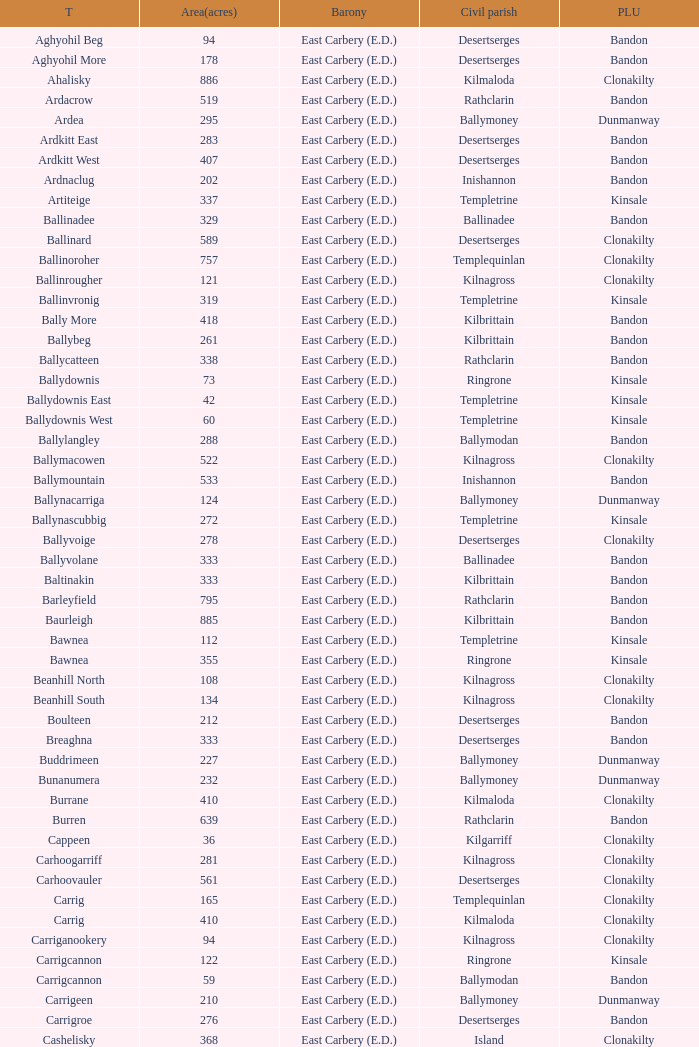Parse the table in full. {'header': ['T', 'Area(acres)', 'Barony', 'Civil parish', 'PLU'], 'rows': [['Aghyohil Beg', '94', 'East Carbery (E.D.)', 'Desertserges', 'Bandon'], ['Aghyohil More', '178', 'East Carbery (E.D.)', 'Desertserges', 'Bandon'], ['Ahalisky', '886', 'East Carbery (E.D.)', 'Kilmaloda', 'Clonakilty'], ['Ardacrow', '519', 'East Carbery (E.D.)', 'Rathclarin', 'Bandon'], ['Ardea', '295', 'East Carbery (E.D.)', 'Ballymoney', 'Dunmanway'], ['Ardkitt East', '283', 'East Carbery (E.D.)', 'Desertserges', 'Bandon'], ['Ardkitt West', '407', 'East Carbery (E.D.)', 'Desertserges', 'Bandon'], ['Ardnaclug', '202', 'East Carbery (E.D.)', 'Inishannon', 'Bandon'], ['Artiteige', '337', 'East Carbery (E.D.)', 'Templetrine', 'Kinsale'], ['Ballinadee', '329', 'East Carbery (E.D.)', 'Ballinadee', 'Bandon'], ['Ballinard', '589', 'East Carbery (E.D.)', 'Desertserges', 'Clonakilty'], ['Ballinoroher', '757', 'East Carbery (E.D.)', 'Templequinlan', 'Clonakilty'], ['Ballinrougher', '121', 'East Carbery (E.D.)', 'Kilnagross', 'Clonakilty'], ['Ballinvronig', '319', 'East Carbery (E.D.)', 'Templetrine', 'Kinsale'], ['Bally More', '418', 'East Carbery (E.D.)', 'Kilbrittain', 'Bandon'], ['Ballybeg', '261', 'East Carbery (E.D.)', 'Kilbrittain', 'Bandon'], ['Ballycatteen', '338', 'East Carbery (E.D.)', 'Rathclarin', 'Bandon'], ['Ballydownis', '73', 'East Carbery (E.D.)', 'Ringrone', 'Kinsale'], ['Ballydownis East', '42', 'East Carbery (E.D.)', 'Templetrine', 'Kinsale'], ['Ballydownis West', '60', 'East Carbery (E.D.)', 'Templetrine', 'Kinsale'], ['Ballylangley', '288', 'East Carbery (E.D.)', 'Ballymodan', 'Bandon'], ['Ballymacowen', '522', 'East Carbery (E.D.)', 'Kilnagross', 'Clonakilty'], ['Ballymountain', '533', 'East Carbery (E.D.)', 'Inishannon', 'Bandon'], ['Ballynacarriga', '124', 'East Carbery (E.D.)', 'Ballymoney', 'Dunmanway'], ['Ballynascubbig', '272', 'East Carbery (E.D.)', 'Templetrine', 'Kinsale'], ['Ballyvoige', '278', 'East Carbery (E.D.)', 'Desertserges', 'Clonakilty'], ['Ballyvolane', '333', 'East Carbery (E.D.)', 'Ballinadee', 'Bandon'], ['Baltinakin', '333', 'East Carbery (E.D.)', 'Kilbrittain', 'Bandon'], ['Barleyfield', '795', 'East Carbery (E.D.)', 'Rathclarin', 'Bandon'], ['Baurleigh', '885', 'East Carbery (E.D.)', 'Kilbrittain', 'Bandon'], ['Bawnea', '112', 'East Carbery (E.D.)', 'Templetrine', 'Kinsale'], ['Bawnea', '355', 'East Carbery (E.D.)', 'Ringrone', 'Kinsale'], ['Beanhill North', '108', 'East Carbery (E.D.)', 'Kilnagross', 'Clonakilty'], ['Beanhill South', '134', 'East Carbery (E.D.)', 'Kilnagross', 'Clonakilty'], ['Boulteen', '212', 'East Carbery (E.D.)', 'Desertserges', 'Bandon'], ['Breaghna', '333', 'East Carbery (E.D.)', 'Desertserges', 'Bandon'], ['Buddrimeen', '227', 'East Carbery (E.D.)', 'Ballymoney', 'Dunmanway'], ['Bunanumera', '232', 'East Carbery (E.D.)', 'Ballymoney', 'Dunmanway'], ['Burrane', '410', 'East Carbery (E.D.)', 'Kilmaloda', 'Clonakilty'], ['Burren', '639', 'East Carbery (E.D.)', 'Rathclarin', 'Bandon'], ['Cappeen', '36', 'East Carbery (E.D.)', 'Kilgarriff', 'Clonakilty'], ['Carhoogarriff', '281', 'East Carbery (E.D.)', 'Kilnagross', 'Clonakilty'], ['Carhoovauler', '561', 'East Carbery (E.D.)', 'Desertserges', 'Clonakilty'], ['Carrig', '165', 'East Carbery (E.D.)', 'Templequinlan', 'Clonakilty'], ['Carrig', '410', 'East Carbery (E.D.)', 'Kilmaloda', 'Clonakilty'], ['Carriganookery', '94', 'East Carbery (E.D.)', 'Kilnagross', 'Clonakilty'], ['Carrigcannon', '122', 'East Carbery (E.D.)', 'Ringrone', 'Kinsale'], ['Carrigcannon', '59', 'East Carbery (E.D.)', 'Ballymodan', 'Bandon'], ['Carrigeen', '210', 'East Carbery (E.D.)', 'Ballymoney', 'Dunmanway'], ['Carrigroe', '276', 'East Carbery (E.D.)', 'Desertserges', 'Bandon'], ['Cashelisky', '368', 'East Carbery (E.D.)', 'Island', 'Clonakilty'], ['Castlederry', '148', 'East Carbery (E.D.)', 'Desertserges', 'Clonakilty'], ['Clashafree', '477', 'East Carbery (E.D.)', 'Ballymodan', 'Bandon'], ['Clashreagh', '132', 'East Carbery (E.D.)', 'Templetrine', 'Kinsale'], ['Clogagh North', '173', 'East Carbery (E.D.)', 'Kilmaloda', 'Clonakilty'], ['Clogagh South', '282', 'East Carbery (E.D.)', 'Kilmaloda', 'Clonakilty'], ['Cloghane', '488', 'East Carbery (E.D.)', 'Ballinadee', 'Bandon'], ['Clogheenavodig', '70', 'East Carbery (E.D.)', 'Ballymodan', 'Bandon'], ['Cloghmacsimon', '258', 'East Carbery (E.D.)', 'Ballymodan', 'Bandon'], ['Cloheen', '360', 'East Carbery (E.D.)', 'Kilgarriff', 'Clonakilty'], ['Cloheen', '80', 'East Carbery (E.D.)', 'Island', 'Clonakilty'], ['Clonbouig', '209', 'East Carbery (E.D.)', 'Templetrine', 'Kinsale'], ['Clonbouig', '219', 'East Carbery (E.D.)', 'Ringrone', 'Kinsale'], ['Cloncouse', '241', 'East Carbery (E.D.)', 'Ballinadee', 'Bandon'], ['Clooncalla Beg', '219', 'East Carbery (E.D.)', 'Rathclarin', 'Bandon'], ['Clooncalla More', '543', 'East Carbery (E.D.)', 'Rathclarin', 'Bandon'], ['Cloonderreen', '291', 'East Carbery (E.D.)', 'Rathclarin', 'Bandon'], ['Coolmain', '450', 'East Carbery (E.D.)', 'Ringrone', 'Kinsale'], ['Corravreeda East', '258', 'East Carbery (E.D.)', 'Ballymodan', 'Bandon'], ['Corravreeda West', '169', 'East Carbery (E.D.)', 'Ballymodan', 'Bandon'], ['Cripplehill', '125', 'East Carbery (E.D.)', 'Ballymodan', 'Bandon'], ['Cripplehill', '93', 'East Carbery (E.D.)', 'Kilbrittain', 'Bandon'], ['Crohane', '91', 'East Carbery (E.D.)', 'Kilnagross', 'Clonakilty'], ['Crohane East', '108', 'East Carbery (E.D.)', 'Desertserges', 'Clonakilty'], ['Crohane West', '69', 'East Carbery (E.D.)', 'Desertserges', 'Clonakilty'], ['Crohane (or Bandon)', '204', 'East Carbery (E.D.)', 'Desertserges', 'Clonakilty'], ['Crohane (or Bandon)', '250', 'East Carbery (E.D.)', 'Kilnagross', 'Clonakilty'], ['Currabeg', '173', 'East Carbery (E.D.)', 'Ballymoney', 'Dunmanway'], ['Curraghcrowly East', '327', 'East Carbery (E.D.)', 'Ballymoney', 'Dunmanway'], ['Curraghcrowly West', '242', 'East Carbery (E.D.)', 'Ballymoney', 'Dunmanway'], ['Curraghgrane More', '110', 'East Carbery (E.D.)', 'Desert', 'Clonakilty'], ['Currane', '156', 'East Carbery (E.D.)', 'Desertserges', 'Clonakilty'], ['Curranure', '362', 'East Carbery (E.D.)', 'Inishannon', 'Bandon'], ['Currarane', '100', 'East Carbery (E.D.)', 'Templetrine', 'Kinsale'], ['Currarane', '271', 'East Carbery (E.D.)', 'Ringrone', 'Kinsale'], ['Derrigra', '177', 'East Carbery (E.D.)', 'Ballymoney', 'Dunmanway'], ['Derrigra West', '320', 'East Carbery (E.D.)', 'Ballymoney', 'Dunmanway'], ['Derry', '140', 'East Carbery (E.D.)', 'Desertserges', 'Clonakilty'], ['Derrymeeleen', '441', 'East Carbery (E.D.)', 'Desertserges', 'Clonakilty'], ['Desert', '339', 'East Carbery (E.D.)', 'Desert', 'Clonakilty'], ['Drombofinny', '86', 'East Carbery (E.D.)', 'Desertserges', 'Bandon'], ['Dromgarriff', '335', 'East Carbery (E.D.)', 'Kilmaloda', 'Clonakilty'], ['Dromgarriff East', '385', 'East Carbery (E.D.)', 'Kilnagross', 'Clonakilty'], ['Dromgarriff West', '138', 'East Carbery (E.D.)', 'Kilnagross', 'Clonakilty'], ['Dromkeen', '673', 'East Carbery (E.D.)', 'Inishannon', 'Bandon'], ['Edencurra', '516', 'East Carbery (E.D.)', 'Ballymoney', 'Dunmanway'], ['Farran', '502', 'East Carbery (E.D.)', 'Kilmaloda', 'Clonakilty'], ['Farranagow', '99', 'East Carbery (E.D.)', 'Inishannon', 'Bandon'], ['Farrannagark', '290', 'East Carbery (E.D.)', 'Rathclarin', 'Bandon'], ['Farrannasheshery', '304', 'East Carbery (E.D.)', 'Desertserges', 'Bandon'], ['Fourcuil', '125', 'East Carbery (E.D.)', 'Kilgarriff', 'Clonakilty'], ['Fourcuil', '244', 'East Carbery (E.D.)', 'Templebryan', 'Clonakilty'], ['Garranbeg', '170', 'East Carbery (E.D.)', 'Ballymodan', 'Bandon'], ['Garraneanasig', '270', 'East Carbery (E.D.)', 'Ringrone', 'Kinsale'], ['Garraneard', '276', 'East Carbery (E.D.)', 'Kilnagross', 'Clonakilty'], ['Garranecore', '144', 'East Carbery (E.D.)', 'Templebryan', 'Clonakilty'], ['Garranecore', '186', 'East Carbery (E.D.)', 'Kilgarriff', 'Clonakilty'], ['Garranefeen', '478', 'East Carbery (E.D.)', 'Rathclarin', 'Bandon'], ['Garraneishal', '121', 'East Carbery (E.D.)', 'Kilnagross', 'Clonakilty'], ['Garranelahan', '126', 'East Carbery (E.D.)', 'Desertserges', 'Bandon'], ['Garranereagh', '398', 'East Carbery (E.D.)', 'Ringrone', 'Kinsale'], ['Garranes', '416', 'East Carbery (E.D.)', 'Desertserges', 'Clonakilty'], ['Garranure', '436', 'East Carbery (E.D.)', 'Ballymoney', 'Dunmanway'], ['Garryndruig', '856', 'East Carbery (E.D.)', 'Rathclarin', 'Bandon'], ['Glan', '194', 'East Carbery (E.D.)', 'Ballymoney', 'Dunmanway'], ['Glanavaud', '98', 'East Carbery (E.D.)', 'Ringrone', 'Kinsale'], ['Glanavirane', '107', 'East Carbery (E.D.)', 'Templetrine', 'Kinsale'], ['Glanavirane', '91', 'East Carbery (E.D.)', 'Ringrone', 'Kinsale'], ['Glanduff', '464', 'East Carbery (E.D.)', 'Rathclarin', 'Bandon'], ['Grillagh', '136', 'East Carbery (E.D.)', 'Kilnagross', 'Clonakilty'], ['Grillagh', '316', 'East Carbery (E.D.)', 'Ballymoney', 'Dunmanway'], ['Hacketstown', '182', 'East Carbery (E.D.)', 'Templetrine', 'Kinsale'], ['Inchafune', '871', 'East Carbery (E.D.)', 'Ballymoney', 'Dunmanway'], ['Inchydoney Island', '474', 'East Carbery (E.D.)', 'Island', 'Clonakilty'], ['Kilbeloge', '216', 'East Carbery (E.D.)', 'Desertserges', 'Clonakilty'], ['Kilbree', '284', 'East Carbery (E.D.)', 'Island', 'Clonakilty'], ['Kilbrittain', '483', 'East Carbery (E.D.)', 'Kilbrittain', 'Bandon'], ['Kilcaskan', '221', 'East Carbery (E.D.)', 'Ballymoney', 'Dunmanway'], ['Kildarra', '463', 'East Carbery (E.D.)', 'Ballinadee', 'Bandon'], ['Kilgarriff', '835', 'East Carbery (E.D.)', 'Kilgarriff', 'Clonakilty'], ['Kilgobbin', '1263', 'East Carbery (E.D.)', 'Ballinadee', 'Bandon'], ['Kill North', '136', 'East Carbery (E.D.)', 'Desertserges', 'Clonakilty'], ['Kill South', '139', 'East Carbery (E.D.)', 'Desertserges', 'Clonakilty'], ['Killanamaul', '220', 'East Carbery (E.D.)', 'Kilbrittain', 'Bandon'], ['Killaneetig', '342', 'East Carbery (E.D.)', 'Ballinadee', 'Bandon'], ['Killavarrig', '708', 'East Carbery (E.D.)', 'Timoleague', 'Clonakilty'], ['Killeen', '309', 'East Carbery (E.D.)', 'Desertserges', 'Clonakilty'], ['Killeens', '132', 'East Carbery (E.D.)', 'Templetrine', 'Kinsale'], ['Kilmacsimon', '219', 'East Carbery (E.D.)', 'Ballinadee', 'Bandon'], ['Kilmaloda', '634', 'East Carbery (E.D.)', 'Kilmaloda', 'Clonakilty'], ['Kilmoylerane North', '306', 'East Carbery (E.D.)', 'Desertserges', 'Clonakilty'], ['Kilmoylerane South', '324', 'East Carbery (E.D.)', 'Desertserges', 'Clonakilty'], ['Kilnameela', '397', 'East Carbery (E.D.)', 'Desertserges', 'Bandon'], ['Kilrush', '189', 'East Carbery (E.D.)', 'Desertserges', 'Bandon'], ['Kilshinahan', '528', 'East Carbery (E.D.)', 'Kilbrittain', 'Bandon'], ['Kilvinane', '199', 'East Carbery (E.D.)', 'Ballymoney', 'Dunmanway'], ['Kilvurra', '356', 'East Carbery (E.D.)', 'Ballymoney', 'Dunmanway'], ['Knockacullen', '381', 'East Carbery (E.D.)', 'Desertserges', 'Clonakilty'], ['Knockaneady', '393', 'East Carbery (E.D.)', 'Ballymoney', 'Dunmanway'], ['Knockaneroe', '127', 'East Carbery (E.D.)', 'Templetrine', 'Kinsale'], ['Knockanreagh', '139', 'East Carbery (E.D.)', 'Ballymodan', 'Bandon'], ['Knockbrown', '312', 'East Carbery (E.D.)', 'Kilbrittain', 'Bandon'], ['Knockbrown', '510', 'East Carbery (E.D.)', 'Kilmaloda', 'Bandon'], ['Knockeenbwee Lower', '213', 'East Carbery (E.D.)', 'Dromdaleague', 'Skibbereen'], ['Knockeenbwee Upper', '229', 'East Carbery (E.D.)', 'Dromdaleague', 'Skibbereen'], ['Knockeencon', '108', 'East Carbery (E.D.)', 'Tullagh', 'Skibbereen'], ['Knockmacool', '241', 'East Carbery (E.D.)', 'Desertserges', 'Bandon'], ['Knocknacurra', '422', 'East Carbery (E.D.)', 'Ballinadee', 'Bandon'], ['Knocknagappul', '507', 'East Carbery (E.D.)', 'Ballinadee', 'Bandon'], ['Knocknanuss', '394', 'East Carbery (E.D.)', 'Desertserges', 'Clonakilty'], ['Knocknastooka', '118', 'East Carbery (E.D.)', 'Desertserges', 'Bandon'], ['Knockroe', '601', 'East Carbery (E.D.)', 'Inishannon', 'Bandon'], ['Knocks', '540', 'East Carbery (E.D.)', 'Desertserges', 'Clonakilty'], ['Knockskagh', '489', 'East Carbery (E.D.)', 'Kilgarriff', 'Clonakilty'], ['Knoppoge', '567', 'East Carbery (E.D.)', 'Kilbrittain', 'Bandon'], ['Lackanalooha', '209', 'East Carbery (E.D.)', 'Kilnagross', 'Clonakilty'], ['Lackenagobidane', '48', 'East Carbery (E.D.)', 'Island', 'Clonakilty'], ['Lisbehegh', '255', 'East Carbery (E.D.)', 'Desertserges', 'Clonakilty'], ['Lisheen', '44', 'East Carbery (E.D.)', 'Templetrine', 'Kinsale'], ['Lisheenaleen', '267', 'East Carbery (E.D.)', 'Rathclarin', 'Bandon'], ['Lisnacunna', '529', 'East Carbery (E.D.)', 'Desertserges', 'Bandon'], ['Lisroe', '91', 'East Carbery (E.D.)', 'Kilgarriff', 'Clonakilty'], ['Lissaphooca', '513', 'East Carbery (E.D.)', 'Ballymodan', 'Bandon'], ['Lisselane', '429', 'East Carbery (E.D.)', 'Kilnagross', 'Clonakilty'], ['Madame', '273', 'East Carbery (E.D.)', 'Kilmaloda', 'Clonakilty'], ['Madame', '41', 'East Carbery (E.D.)', 'Kilnagross', 'Clonakilty'], ['Maulbrack East', '100', 'East Carbery (E.D.)', 'Desertserges', 'Bandon'], ['Maulbrack West', '242', 'East Carbery (E.D.)', 'Desertserges', 'Bandon'], ['Maulmane', '219', 'East Carbery (E.D.)', 'Kilbrittain', 'Bandon'], ['Maulnageragh', '135', 'East Carbery (E.D.)', 'Kilnagross', 'Clonakilty'], ['Maulnarouga North', '81', 'East Carbery (E.D.)', 'Desertserges', 'Bandon'], ['Maulnarouga South', '374', 'East Carbery (E.D.)', 'Desertserges', 'Bandon'], ['Maulnaskehy', '14', 'East Carbery (E.D.)', 'Kilgarriff', 'Clonakilty'], ['Maulrour', '244', 'East Carbery (E.D.)', 'Desertserges', 'Clonakilty'], ['Maulrour', '340', 'East Carbery (E.D.)', 'Kilmaloda', 'Clonakilty'], ['Maulskinlahane', '245', 'East Carbery (E.D.)', 'Kilbrittain', 'Bandon'], ['Miles', '268', 'East Carbery (E.D.)', 'Kilgarriff', 'Clonakilty'], ['Moanarone', '235', 'East Carbery (E.D.)', 'Ballymodan', 'Bandon'], ['Monteen', '589', 'East Carbery (E.D.)', 'Kilmaloda', 'Clonakilty'], ['Phale Lower', '287', 'East Carbery (E.D.)', 'Ballymoney', 'Dunmanway'], ['Phale Upper', '234', 'East Carbery (E.D.)', 'Ballymoney', 'Dunmanway'], ['Ratharoon East', '810', 'East Carbery (E.D.)', 'Ballinadee', 'Bandon'], ['Ratharoon West', '383', 'East Carbery (E.D.)', 'Ballinadee', 'Bandon'], ['Rathdrought', '1242', 'East Carbery (E.D.)', 'Ballinadee', 'Bandon'], ['Reengarrigeen', '560', 'East Carbery (E.D.)', 'Kilmaloda', 'Clonakilty'], ['Reenroe', '123', 'East Carbery (E.D.)', 'Kilgarriff', 'Clonakilty'], ['Rochestown', '104', 'East Carbery (E.D.)', 'Templetrine', 'Kinsale'], ['Rockfort', '308', 'East Carbery (E.D.)', 'Brinny', 'Bandon'], ['Rockhouse', '82', 'East Carbery (E.D.)', 'Ballinadee', 'Bandon'], ['Scartagh', '186', 'East Carbery (E.D.)', 'Kilgarriff', 'Clonakilty'], ['Shanakill', '197', 'East Carbery (E.D.)', 'Rathclarin', 'Bandon'], ['Shanaway East', '386', 'East Carbery (E.D.)', 'Ballymoney', 'Dunmanway'], ['Shanaway Middle', '296', 'East Carbery (E.D.)', 'Ballymoney', 'Dunmanway'], ['Shanaway West', '266', 'East Carbery (E.D.)', 'Ballymoney', 'Dunmanway'], ['Skeaf', '452', 'East Carbery (E.D.)', 'Kilmaloda', 'Clonakilty'], ['Skeaf East', '371', 'East Carbery (E.D.)', 'Kilmaloda', 'Clonakilty'], ['Skeaf West', '477', 'East Carbery (E.D.)', 'Kilmaloda', 'Clonakilty'], ['Skevanish', '359', 'East Carbery (E.D.)', 'Inishannon', 'Bandon'], ['Steilaneigh', '42', 'East Carbery (E.D.)', 'Templetrine', 'Kinsale'], ['Tawnies Lower', '238', 'East Carbery (E.D.)', 'Kilgarriff', 'Clonakilty'], ['Tawnies Upper', '321', 'East Carbery (E.D.)', 'Kilgarriff', 'Clonakilty'], ['Templebryan North', '436', 'East Carbery (E.D.)', 'Templebryan', 'Clonakilty'], ['Templebryan South', '363', 'East Carbery (E.D.)', 'Templebryan', 'Clonakilty'], ['Tullig', '135', 'East Carbery (E.D.)', 'Kilmaloda', 'Clonakilty'], ['Tullyland', '348', 'East Carbery (E.D.)', 'Ballymodan', 'Bandon'], ['Tullyland', '506', 'East Carbery (E.D.)', 'Ballinadee', 'Bandon'], ['Tullymurrihy', '665', 'East Carbery (E.D.)', 'Desertserges', 'Bandon'], ['Youghals', '109', 'East Carbery (E.D.)', 'Island', 'Clonakilty']]} What is the poor law union of the Ardacrow townland? Bandon. 